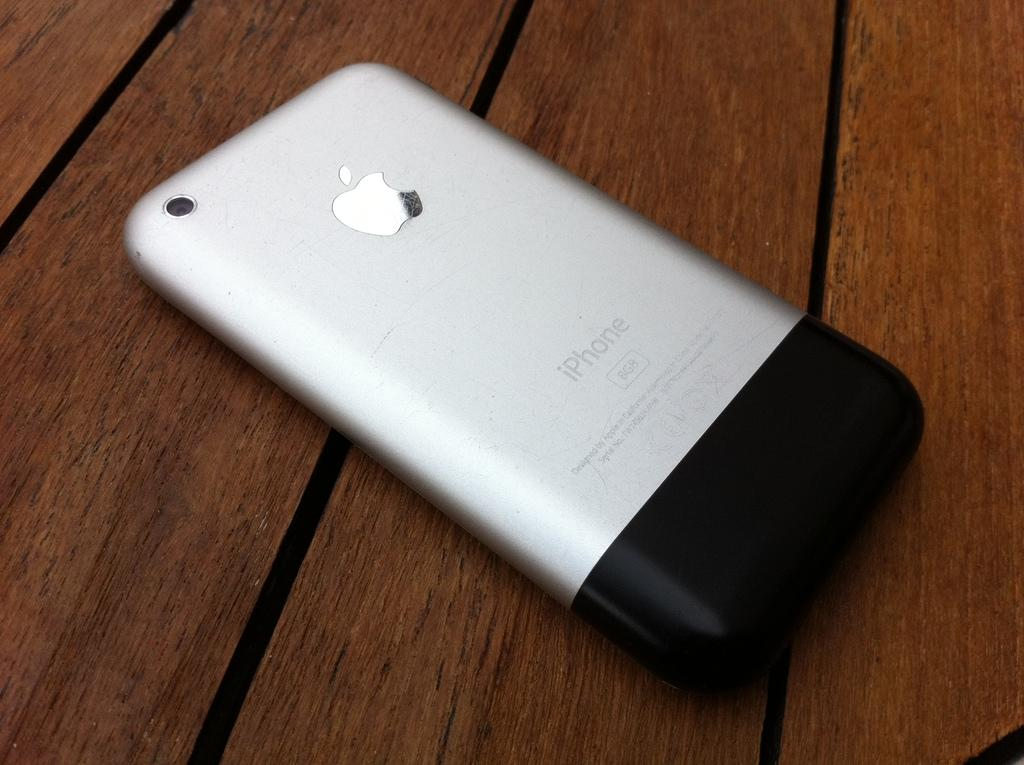<image>
Present a compact description of the photo's key features. The back side of an Apple iphone siver and black and 8gbs. 